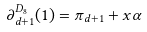<formula> <loc_0><loc_0><loc_500><loc_500>\partial _ { d + 1 } ^ { D _ { 8 } } ( 1 ) = \pi _ { d + 1 } + x \alpha</formula> 